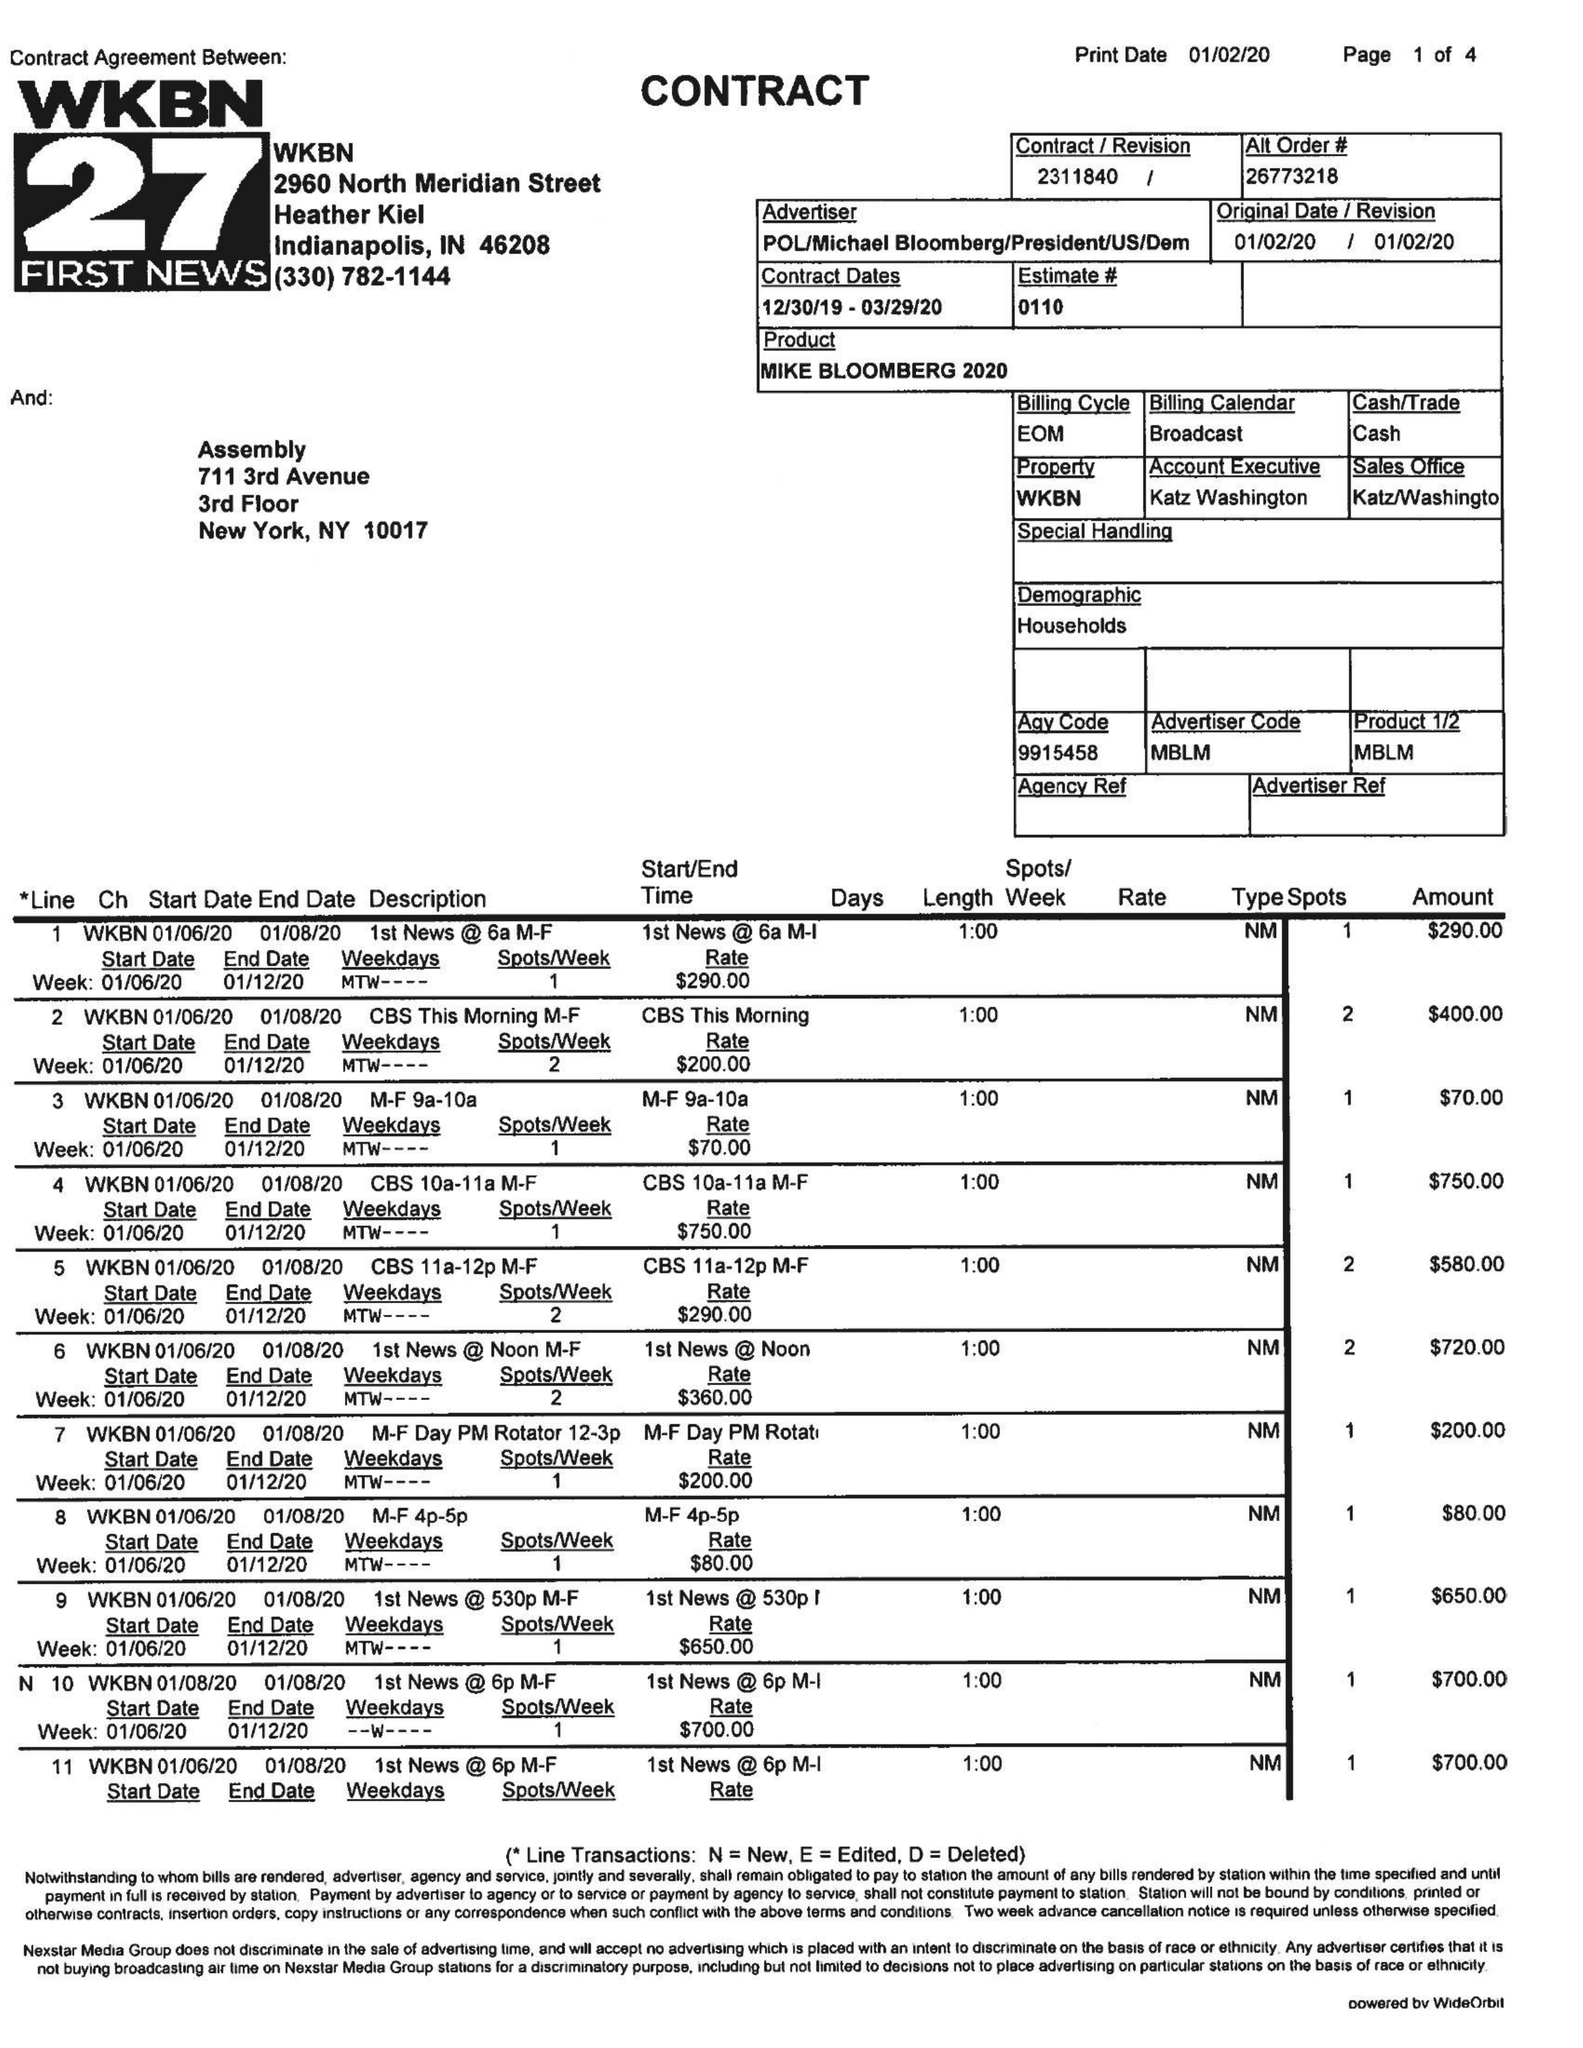What is the value for the gross_amount?
Answer the question using a single word or phrase. 27680.00 